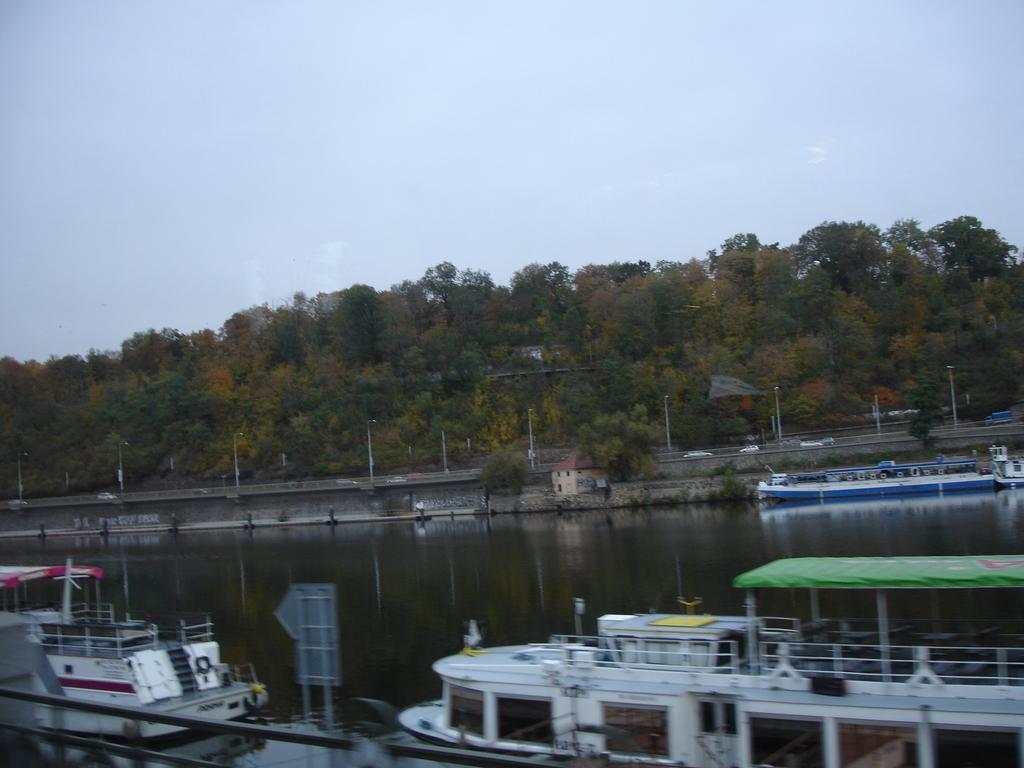Describe this image in one or two sentences. In this image we can see the boats on the surface of the water. We can also see the text board, light poles and also many trees. We can also see the house in the background. At the top we can see the sky. 